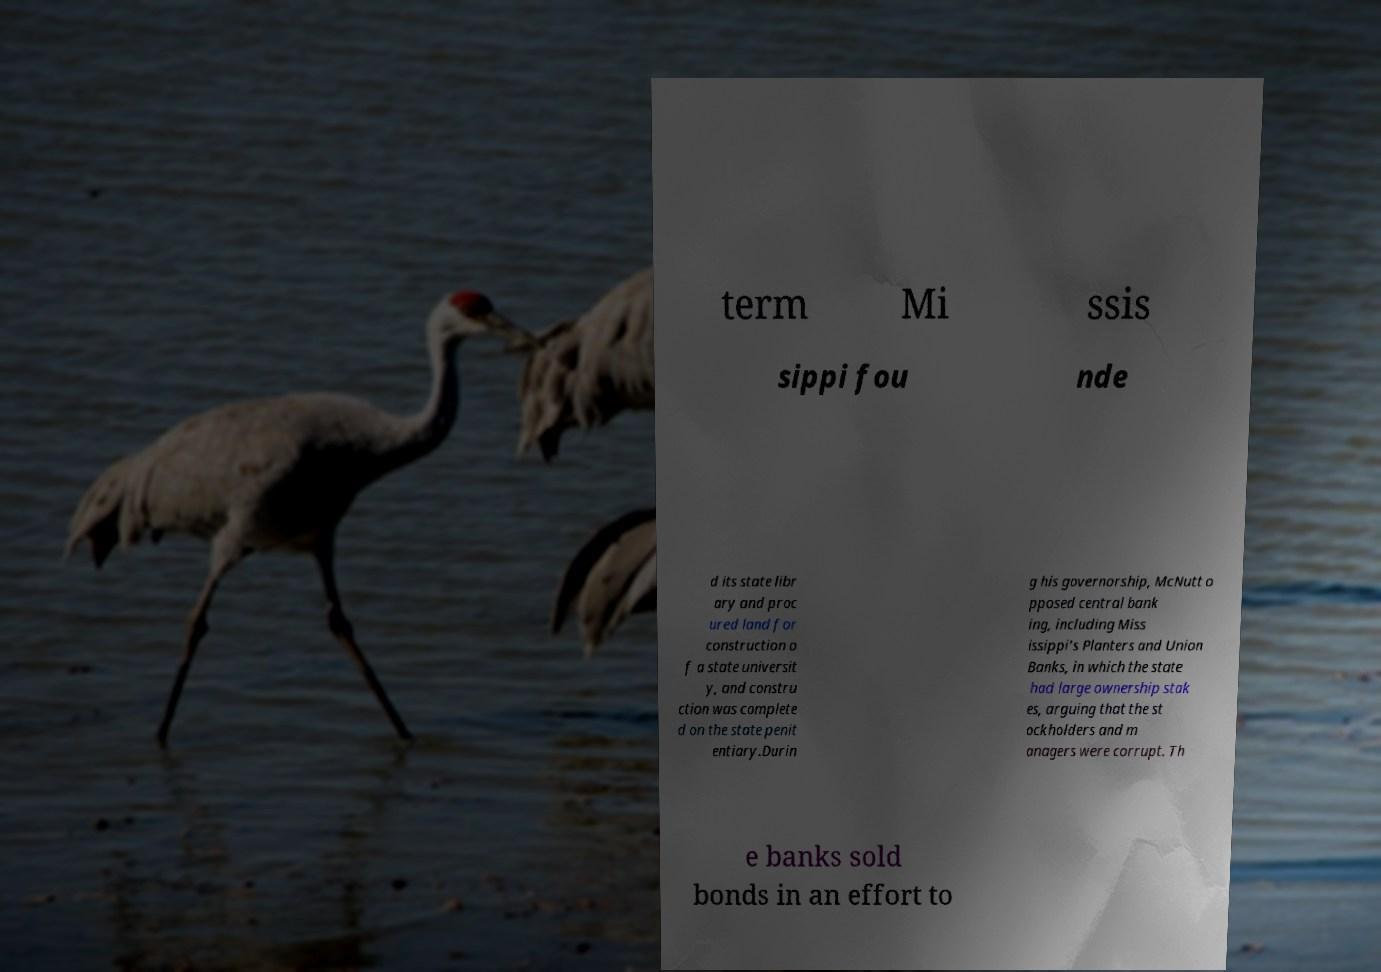For documentation purposes, I need the text within this image transcribed. Could you provide that? term Mi ssis sippi fou nde d its state libr ary and proc ured land for construction o f a state universit y, and constru ction was complete d on the state penit entiary.Durin g his governorship, McNutt o pposed central bank ing, including Miss issippi's Planters and Union Banks, in which the state had large ownership stak es, arguing that the st ockholders and m anagers were corrupt. Th e banks sold bonds in an effort to 